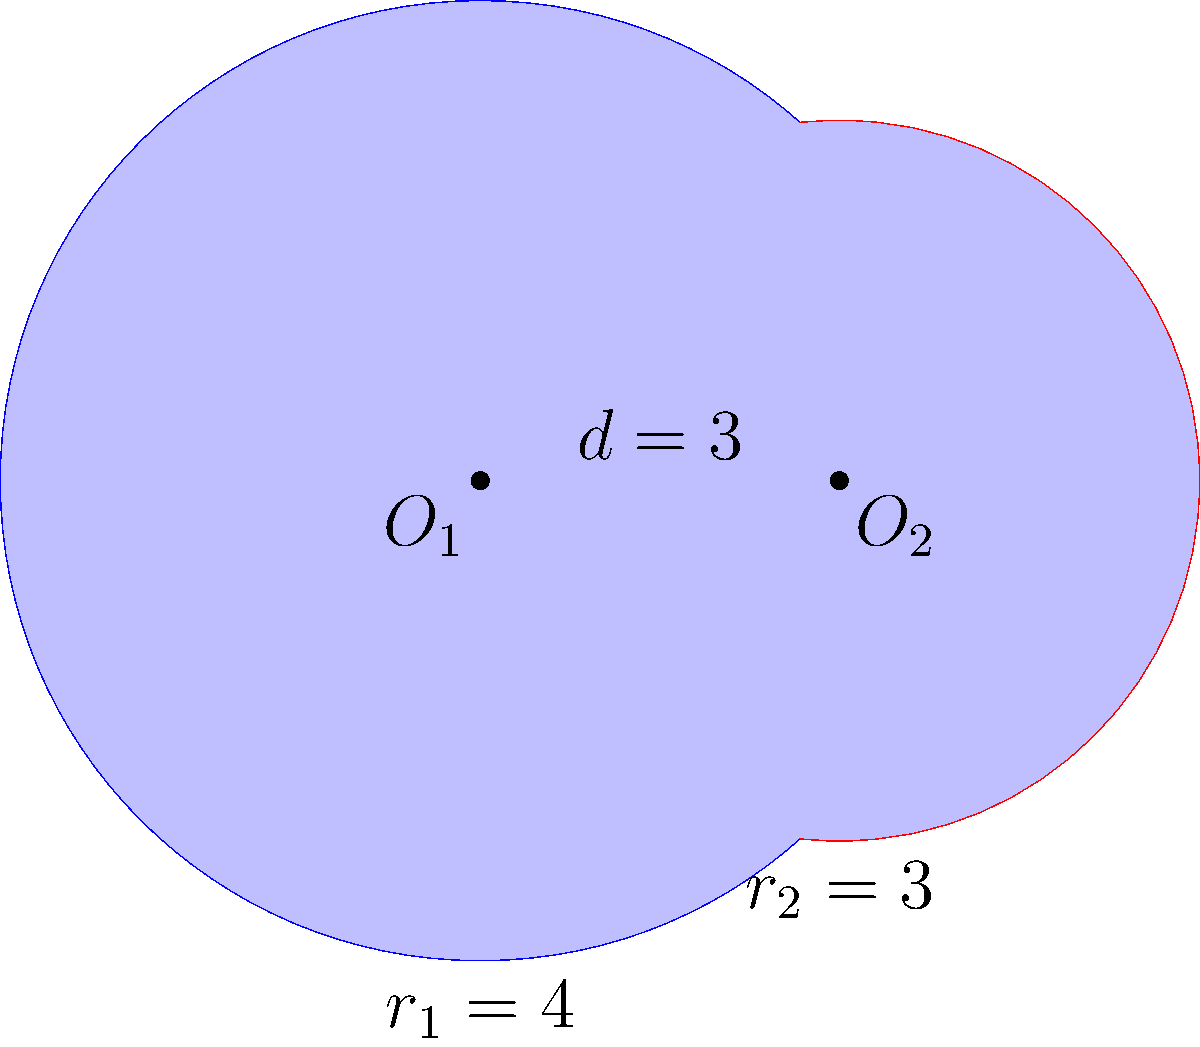In a genomic database visualization, two circular regions of interest are represented by intersecting circles. The first circle, centered at $O_1$, has a radius of 4 units, while the second circle, centered at $O_2$, has a radius of 3 units. The distance between the centers is 3 units. Calculate the area of the shaded region between the two intersecting circles, which represents the overlapping genetic sequences. Express your answer in terms of $\pi$. To find the area of the shaded region, we need to:

1) Calculate the areas of the two circular segments.
2) Add these areas to get the total shaded area.

Let's solve this step-by-step:

1) First, we need to find the central angle $\theta$ for each circle:

   For circle 1: $\cos(\frac{\theta_1}{2}) = \frac{3}{8}$
   $\theta_1 = 2 \arccos(\frac{3}{8}) = 2.0944$ radians

   For circle 2: $\cos(\frac{\theta_2}{2}) = \frac{1}{4}$
   $\theta_2 = 2 \arccos(\frac{1}{4}) = 2.5862$ radians

2) Now, we can calculate the area of each circular segment:

   Area of segment = $r^2 (\theta - \sin\theta)$

   For circle 1: $A_1 = 4^2 (2.0944 - \sin(2.0944)) = 5.0548$
   For circle 2: $A_2 = 3^2 (2.5862 - \sin(2.5862)) = 6.5449$

3) The total shaded area is the sum of these two segments:

   Total Area = $A_1 + A_2 = 5.0548 + 6.5449 = 11.5997$

4) Expressing in terms of $\pi$:

   $11.5997 \approx \frac{11.5997}{\pi} \pi \approx 3.6918\pi$

Therefore, the shaded area is approximately $3.6918\pi$ square units.
Answer: $3.6918\pi$ square units 